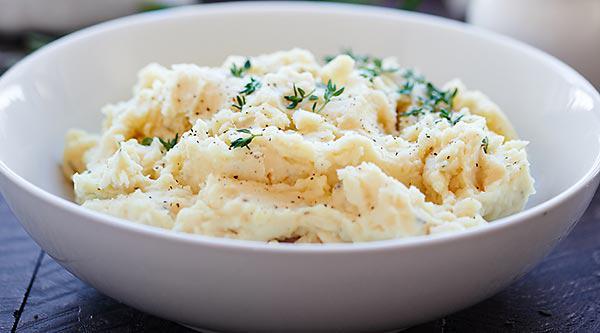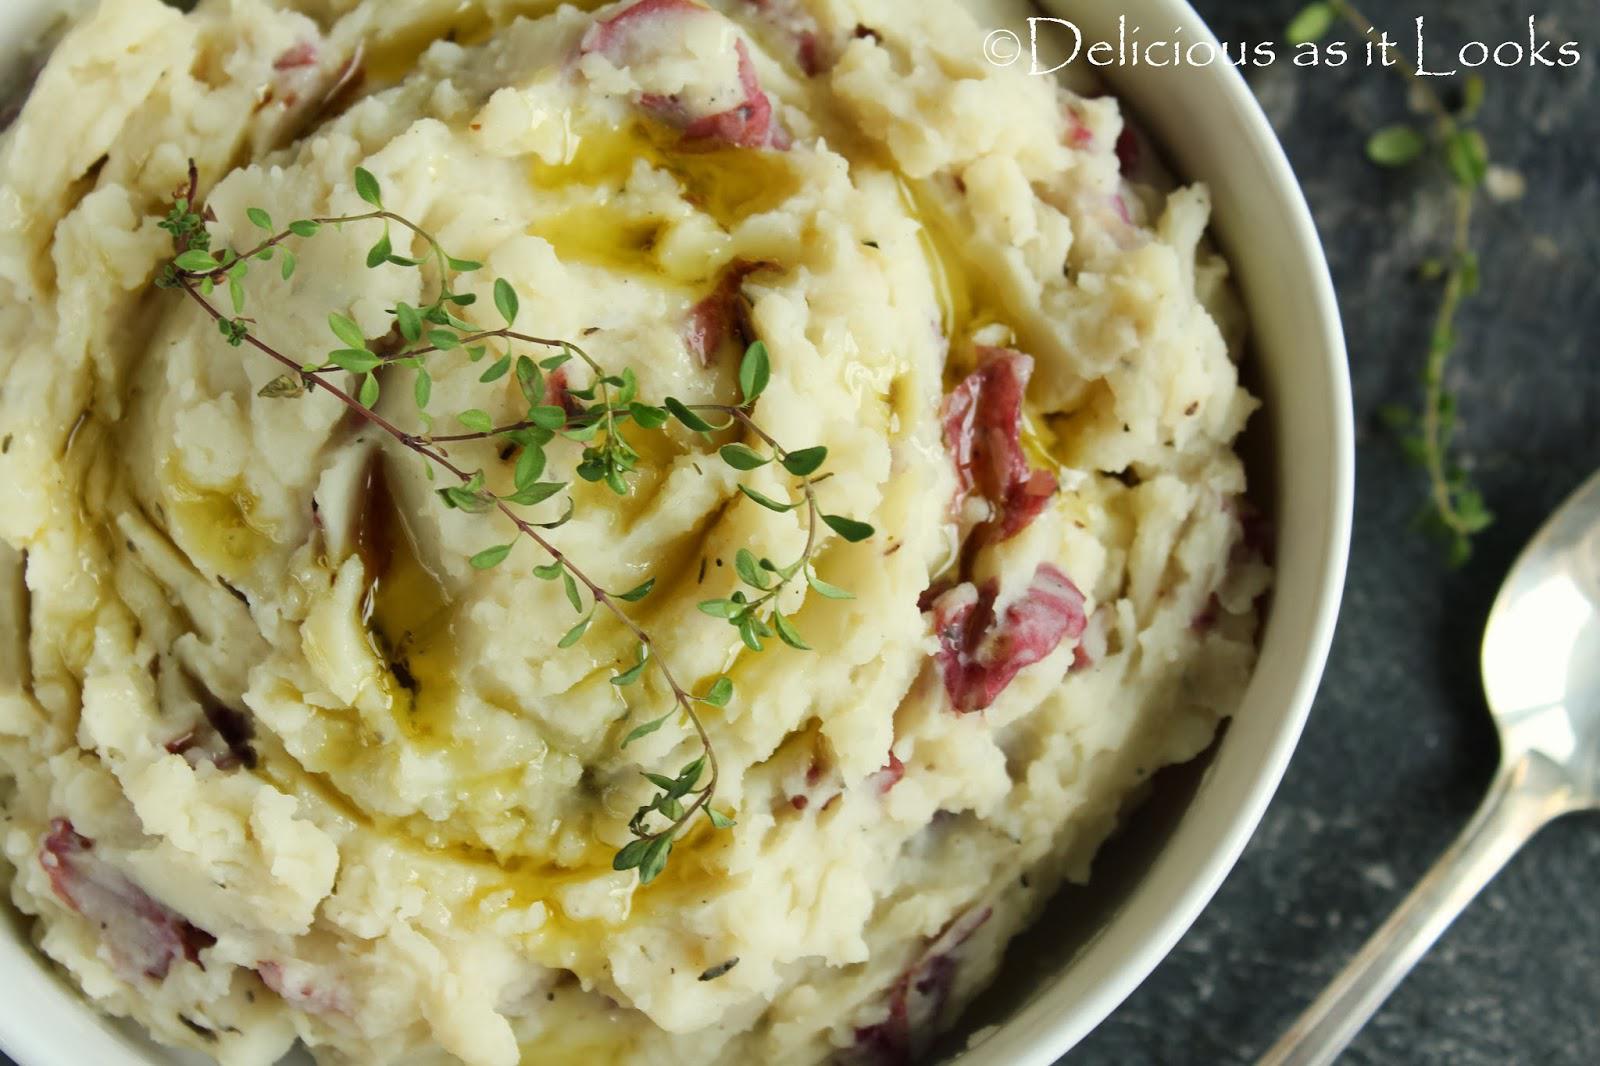The first image is the image on the left, the second image is the image on the right. For the images shown, is this caption "There is a cylindrical, silver pepper grinder behind a bowl of mashed potatoes in one of the images." true? Answer yes or no. No. The first image is the image on the left, the second image is the image on the right. Analyze the images presented: Is the assertion "A cylindrical spice grinder is laying alongside a bowl of mashed potatoes doused with brownish liquid." valid? Answer yes or no. No. 